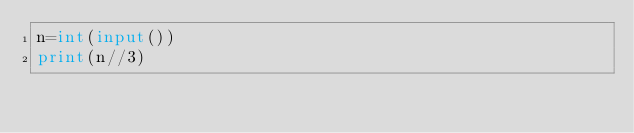Convert code to text. <code><loc_0><loc_0><loc_500><loc_500><_Python_>n=int(input())
print(n//3)</code> 